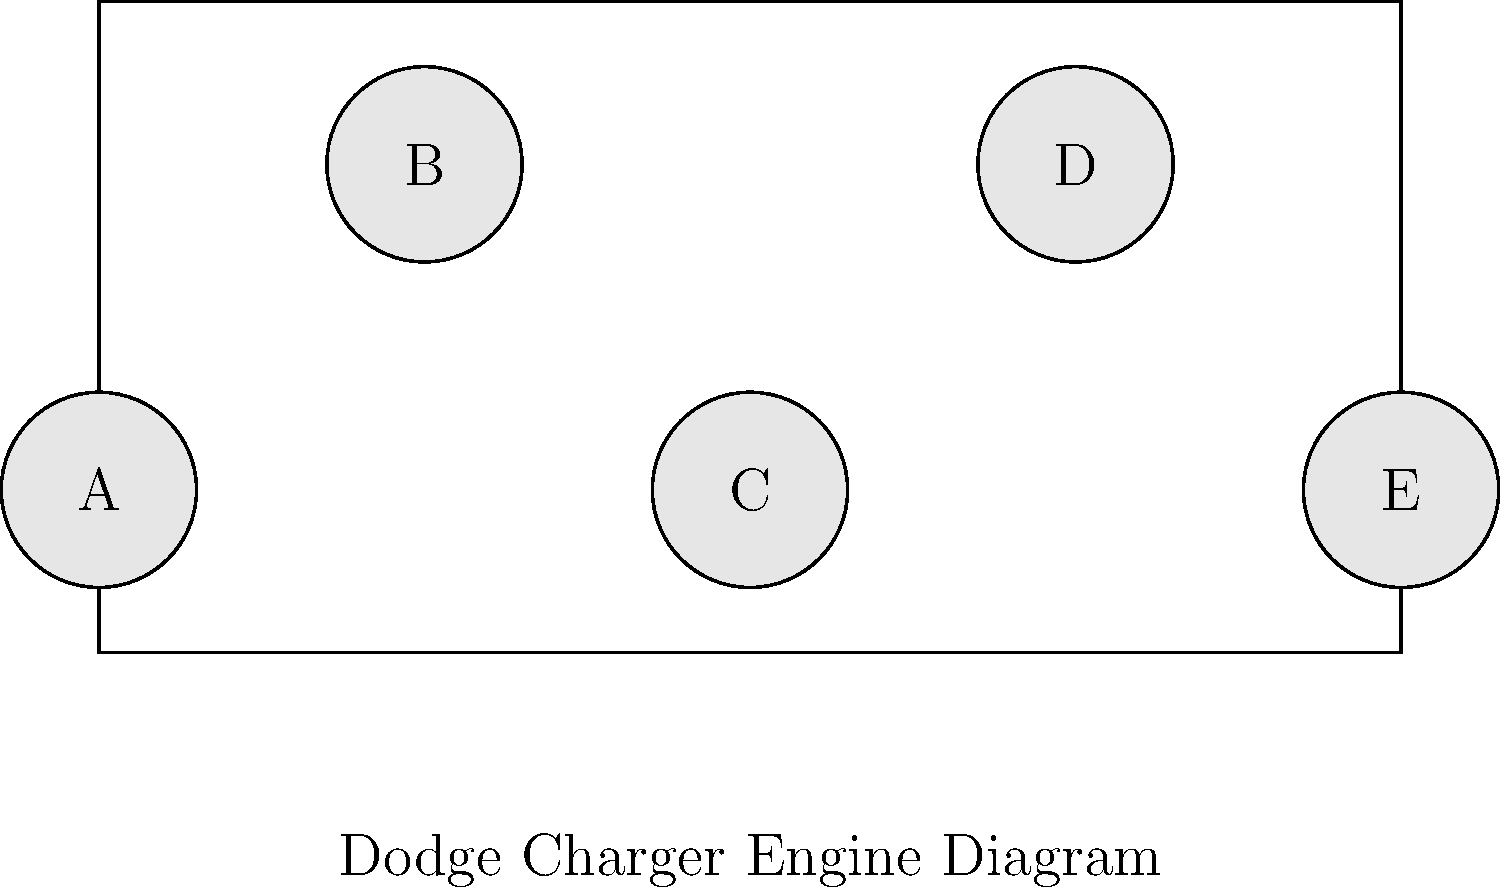In the diagram of a Dodge Charger engine, which component is typically responsible for converting fuel into mechanical energy? To identify the correct component responsible for converting fuel into mechanical energy in a Dodge Charger engine, let's consider the function of each major engine component:

1. Component A: This is likely the alternator, which generates electrical power for the vehicle's systems.
2. Component B: This appears to be the air intake system, which supplies air to the engine.
3. Component C: This central component is most likely the engine block, which houses the cylinders where fuel combustion occurs.
4. Component D: This could represent the exhaust manifold, which collects and directs exhaust gases.
5. Component E: This might be the oil pan, which stores and circulates engine oil.

The component responsible for converting fuel into mechanical energy is the engine block (C). This is where the combustion chambers are located, and where the fuel-air mixture is ignited, driving the pistons and creating the mechanical energy that powers the vehicle.
Answer: C 